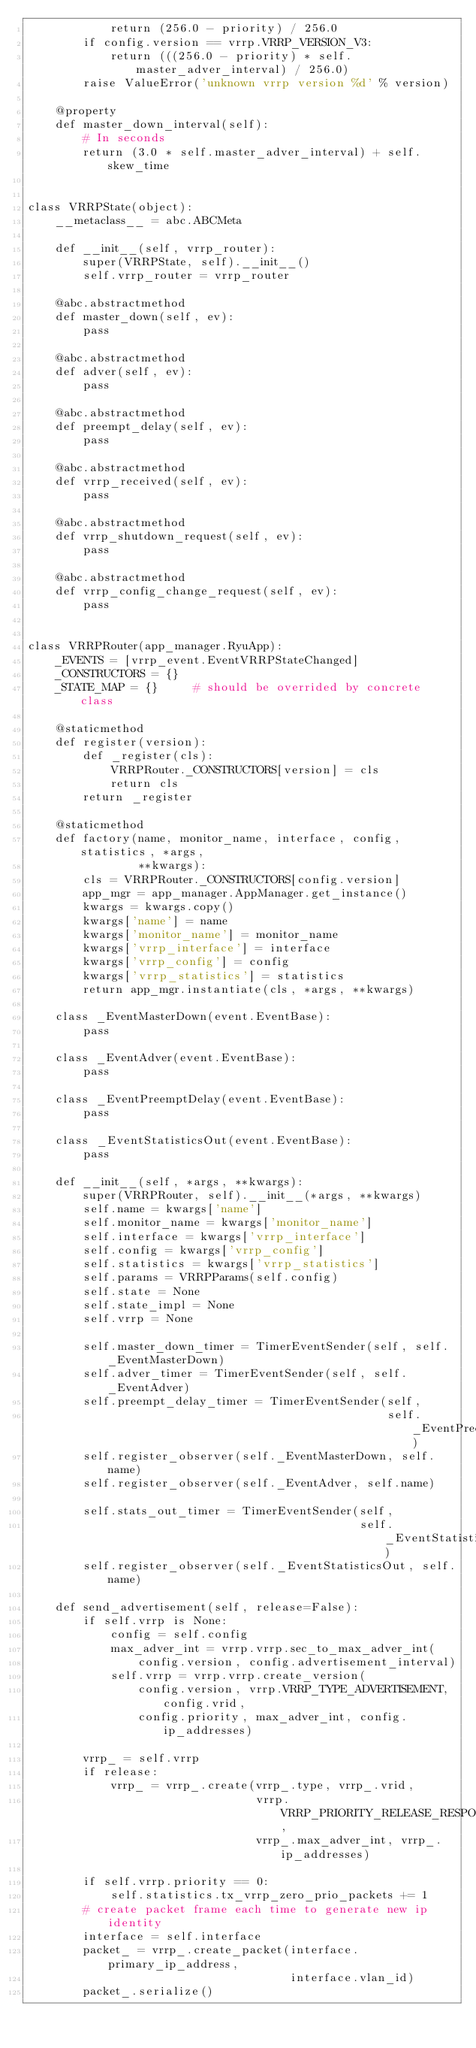<code> <loc_0><loc_0><loc_500><loc_500><_Python_>            return (256.0 - priority) / 256.0
        if config.version == vrrp.VRRP_VERSION_V3:
            return (((256.0 - priority) * self.master_adver_interval) / 256.0)
        raise ValueError('unknown vrrp version %d' % version)

    @property
    def master_down_interval(self):
        # In seconds
        return (3.0 * self.master_adver_interval) + self.skew_time


class VRRPState(object):
    __metaclass__ = abc.ABCMeta

    def __init__(self, vrrp_router):
        super(VRRPState, self).__init__()
        self.vrrp_router = vrrp_router

    @abc.abstractmethod
    def master_down(self, ev):
        pass

    @abc.abstractmethod
    def adver(self, ev):
        pass

    @abc.abstractmethod
    def preempt_delay(self, ev):
        pass

    @abc.abstractmethod
    def vrrp_received(self, ev):
        pass

    @abc.abstractmethod
    def vrrp_shutdown_request(self, ev):
        pass

    @abc.abstractmethod
    def vrrp_config_change_request(self, ev):
        pass


class VRRPRouter(app_manager.RyuApp):
    _EVENTS = [vrrp_event.EventVRRPStateChanged]
    _CONSTRUCTORS = {}
    _STATE_MAP = {}     # should be overrided by concrete class

    @staticmethod
    def register(version):
        def _register(cls):
            VRRPRouter._CONSTRUCTORS[version] = cls
            return cls
        return _register

    @staticmethod
    def factory(name, monitor_name, interface, config, statistics, *args,
                **kwargs):
        cls = VRRPRouter._CONSTRUCTORS[config.version]
        app_mgr = app_manager.AppManager.get_instance()
        kwargs = kwargs.copy()
        kwargs['name'] = name
        kwargs['monitor_name'] = monitor_name
        kwargs['vrrp_interface'] = interface
        kwargs['vrrp_config'] = config
        kwargs['vrrp_statistics'] = statistics
        return app_mgr.instantiate(cls, *args, **kwargs)

    class _EventMasterDown(event.EventBase):
        pass

    class _EventAdver(event.EventBase):
        pass

    class _EventPreemptDelay(event.EventBase):
        pass

    class _EventStatisticsOut(event.EventBase):
        pass

    def __init__(self, *args, **kwargs):
        super(VRRPRouter, self).__init__(*args, **kwargs)
        self.name = kwargs['name']
        self.monitor_name = kwargs['monitor_name']
        self.interface = kwargs['vrrp_interface']
        self.config = kwargs['vrrp_config']
        self.statistics = kwargs['vrrp_statistics']
        self.params = VRRPParams(self.config)
        self.state = None
        self.state_impl = None
        self.vrrp = None

        self.master_down_timer = TimerEventSender(self, self._EventMasterDown)
        self.adver_timer = TimerEventSender(self, self._EventAdver)
        self.preempt_delay_timer = TimerEventSender(self,
                                                    self._EventPreemptDelay)
        self.register_observer(self._EventMasterDown, self.name)
        self.register_observer(self._EventAdver, self.name)

        self.stats_out_timer = TimerEventSender(self,
                                                self._EventStatisticsOut)
        self.register_observer(self._EventStatisticsOut, self.name)

    def send_advertisement(self, release=False):
        if self.vrrp is None:
            config = self.config
            max_adver_int = vrrp.vrrp.sec_to_max_adver_int(
                config.version, config.advertisement_interval)
            self.vrrp = vrrp.vrrp.create_version(
                config.version, vrrp.VRRP_TYPE_ADVERTISEMENT, config.vrid,
                config.priority, max_adver_int, config.ip_addresses)

        vrrp_ = self.vrrp
        if release:
            vrrp_ = vrrp_.create(vrrp_.type, vrrp_.vrid,
                                 vrrp.VRRP_PRIORITY_RELEASE_RESPONSIBILITY,
                                 vrrp_.max_adver_int, vrrp_.ip_addresses)

        if self.vrrp.priority == 0:
            self.statistics.tx_vrrp_zero_prio_packets += 1
        # create packet frame each time to generate new ip identity
        interface = self.interface
        packet_ = vrrp_.create_packet(interface.primary_ip_address,
                                      interface.vlan_id)
        packet_.serialize()</code> 